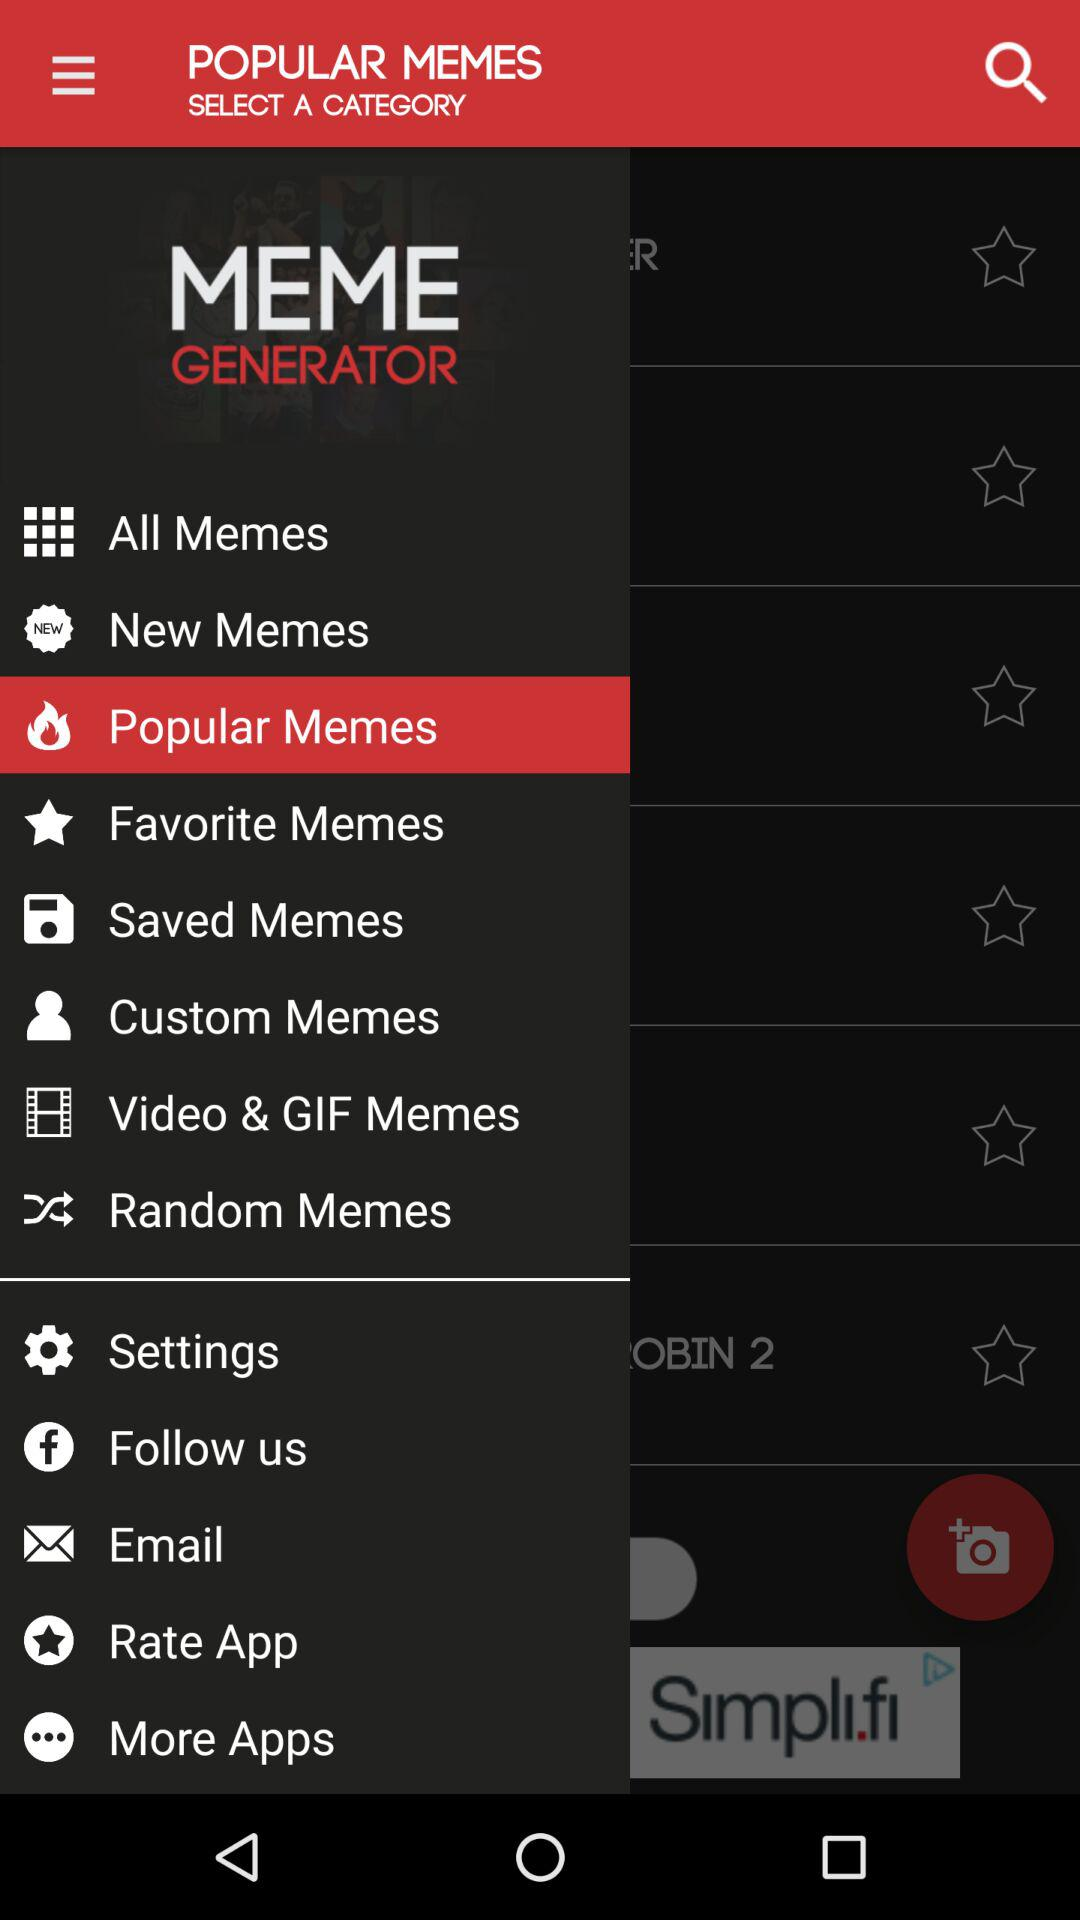Which option is selected? The selected option is "Popular Memes". 